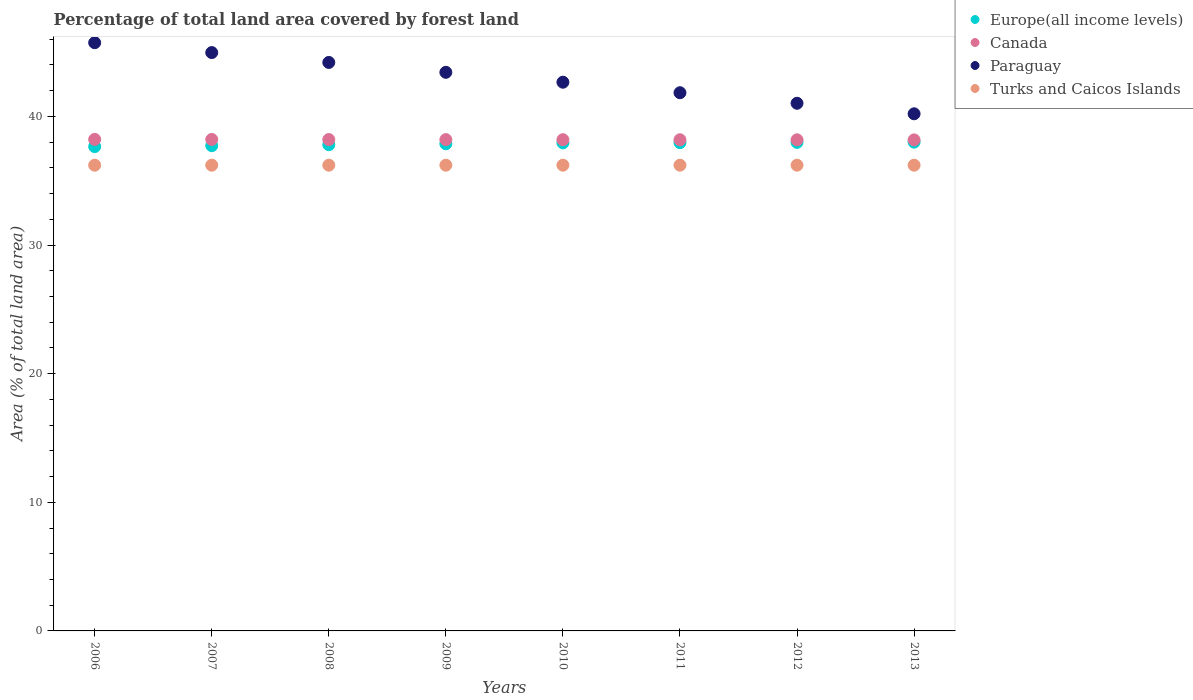How many different coloured dotlines are there?
Provide a succinct answer. 4. What is the percentage of forest land in Paraguay in 2011?
Offer a very short reply. 41.84. Across all years, what is the maximum percentage of forest land in Canada?
Your answer should be compact. 38.22. Across all years, what is the minimum percentage of forest land in Canada?
Your answer should be compact. 38.18. In which year was the percentage of forest land in Turks and Caicos Islands maximum?
Offer a very short reply. 2006. What is the total percentage of forest land in Paraguay in the graph?
Provide a short and direct response. 344.07. What is the difference between the percentage of forest land in Canada in 2009 and the percentage of forest land in Paraguay in 2012?
Ensure brevity in your answer.  -2.83. What is the average percentage of forest land in Canada per year?
Your response must be concise. 38.2. In the year 2013, what is the difference between the percentage of forest land in Paraguay and percentage of forest land in Europe(all income levels)?
Your answer should be compact. 2.2. What is the ratio of the percentage of forest land in Paraguay in 2010 to that in 2013?
Ensure brevity in your answer.  1.06. Is the percentage of forest land in Canada in 2010 less than that in 2013?
Make the answer very short. No. What is the difference between the highest and the second highest percentage of forest land in Paraguay?
Your answer should be compact. 0.77. What is the difference between the highest and the lowest percentage of forest land in Turks and Caicos Islands?
Your answer should be compact. 0. In how many years, is the percentage of forest land in Canada greater than the average percentage of forest land in Canada taken over all years?
Make the answer very short. 4. Is it the case that in every year, the sum of the percentage of forest land in Turks and Caicos Islands and percentage of forest land in Europe(all income levels)  is greater than the sum of percentage of forest land in Paraguay and percentage of forest land in Canada?
Provide a succinct answer. No. Does the percentage of forest land in Turks and Caicos Islands monotonically increase over the years?
Ensure brevity in your answer.  No. Is the percentage of forest land in Europe(all income levels) strictly less than the percentage of forest land in Paraguay over the years?
Keep it short and to the point. Yes. What is the difference between two consecutive major ticks on the Y-axis?
Keep it short and to the point. 10. Does the graph contain any zero values?
Ensure brevity in your answer.  No. Does the graph contain grids?
Your answer should be very brief. No. How are the legend labels stacked?
Offer a very short reply. Vertical. What is the title of the graph?
Offer a very short reply. Percentage of total land area covered by forest land. What is the label or title of the Y-axis?
Ensure brevity in your answer.  Area (% of total land area). What is the Area (% of total land area) of Europe(all income levels) in 2006?
Offer a terse response. 37.66. What is the Area (% of total land area) in Canada in 2006?
Provide a short and direct response. 38.22. What is the Area (% of total land area) of Paraguay in 2006?
Provide a short and direct response. 45.73. What is the Area (% of total land area) of Turks and Caicos Islands in 2006?
Your response must be concise. 36.21. What is the Area (% of total land area) of Europe(all income levels) in 2007?
Provide a succinct answer. 37.73. What is the Area (% of total land area) of Canada in 2007?
Ensure brevity in your answer.  38.21. What is the Area (% of total land area) in Paraguay in 2007?
Your answer should be very brief. 44.97. What is the Area (% of total land area) of Turks and Caicos Islands in 2007?
Provide a succinct answer. 36.21. What is the Area (% of total land area) in Europe(all income levels) in 2008?
Provide a short and direct response. 37.8. What is the Area (% of total land area) in Canada in 2008?
Offer a terse response. 38.2. What is the Area (% of total land area) of Paraguay in 2008?
Your answer should be very brief. 44.2. What is the Area (% of total land area) of Turks and Caicos Islands in 2008?
Your answer should be compact. 36.21. What is the Area (% of total land area) of Europe(all income levels) in 2009?
Your answer should be compact. 37.87. What is the Area (% of total land area) of Canada in 2009?
Ensure brevity in your answer.  38.2. What is the Area (% of total land area) in Paraguay in 2009?
Offer a terse response. 43.43. What is the Area (% of total land area) in Turks and Caicos Islands in 2009?
Ensure brevity in your answer.  36.21. What is the Area (% of total land area) of Europe(all income levels) in 2010?
Provide a succinct answer. 37.94. What is the Area (% of total land area) of Canada in 2010?
Ensure brevity in your answer.  38.19. What is the Area (% of total land area) in Paraguay in 2010?
Make the answer very short. 42.66. What is the Area (% of total land area) of Turks and Caicos Islands in 2010?
Your answer should be compact. 36.21. What is the Area (% of total land area) of Europe(all income levels) in 2011?
Your answer should be very brief. 37.96. What is the Area (% of total land area) in Canada in 2011?
Your answer should be compact. 38.19. What is the Area (% of total land area) of Paraguay in 2011?
Keep it short and to the point. 41.84. What is the Area (% of total land area) in Turks and Caicos Islands in 2011?
Give a very brief answer. 36.21. What is the Area (% of total land area) of Europe(all income levels) in 2012?
Keep it short and to the point. 37.98. What is the Area (% of total land area) of Canada in 2012?
Make the answer very short. 38.18. What is the Area (% of total land area) of Paraguay in 2012?
Give a very brief answer. 41.02. What is the Area (% of total land area) of Turks and Caicos Islands in 2012?
Your response must be concise. 36.21. What is the Area (% of total land area) of Europe(all income levels) in 2013?
Your answer should be very brief. 38. What is the Area (% of total land area) of Canada in 2013?
Offer a very short reply. 38.18. What is the Area (% of total land area) in Paraguay in 2013?
Offer a terse response. 40.21. What is the Area (% of total land area) in Turks and Caicos Islands in 2013?
Your answer should be compact. 36.21. Across all years, what is the maximum Area (% of total land area) in Europe(all income levels)?
Offer a terse response. 38. Across all years, what is the maximum Area (% of total land area) of Canada?
Provide a succinct answer. 38.22. Across all years, what is the maximum Area (% of total land area) of Paraguay?
Make the answer very short. 45.73. Across all years, what is the maximum Area (% of total land area) in Turks and Caicos Islands?
Ensure brevity in your answer.  36.21. Across all years, what is the minimum Area (% of total land area) of Europe(all income levels)?
Offer a very short reply. 37.66. Across all years, what is the minimum Area (% of total land area) in Canada?
Offer a terse response. 38.18. Across all years, what is the minimum Area (% of total land area) in Paraguay?
Your answer should be compact. 40.21. Across all years, what is the minimum Area (% of total land area) in Turks and Caicos Islands?
Ensure brevity in your answer.  36.21. What is the total Area (% of total land area) of Europe(all income levels) in the graph?
Give a very brief answer. 302.95. What is the total Area (% of total land area) of Canada in the graph?
Give a very brief answer. 305.57. What is the total Area (% of total land area) of Paraguay in the graph?
Give a very brief answer. 344.07. What is the total Area (% of total land area) of Turks and Caicos Islands in the graph?
Your answer should be compact. 289.68. What is the difference between the Area (% of total land area) in Europe(all income levels) in 2006 and that in 2007?
Provide a succinct answer. -0.07. What is the difference between the Area (% of total land area) of Canada in 2006 and that in 2007?
Offer a very short reply. 0.01. What is the difference between the Area (% of total land area) of Paraguay in 2006 and that in 2007?
Ensure brevity in your answer.  0.77. What is the difference between the Area (% of total land area) of Europe(all income levels) in 2006 and that in 2008?
Give a very brief answer. -0.15. What is the difference between the Area (% of total land area) in Canada in 2006 and that in 2008?
Your answer should be very brief. 0.01. What is the difference between the Area (% of total land area) of Paraguay in 2006 and that in 2008?
Keep it short and to the point. 1.54. What is the difference between the Area (% of total land area) of Turks and Caicos Islands in 2006 and that in 2008?
Ensure brevity in your answer.  0. What is the difference between the Area (% of total land area) of Europe(all income levels) in 2006 and that in 2009?
Keep it short and to the point. -0.22. What is the difference between the Area (% of total land area) in Canada in 2006 and that in 2009?
Your answer should be very brief. 0.02. What is the difference between the Area (% of total land area) in Paraguay in 2006 and that in 2009?
Ensure brevity in your answer.  2.3. What is the difference between the Area (% of total land area) of Turks and Caicos Islands in 2006 and that in 2009?
Make the answer very short. 0. What is the difference between the Area (% of total land area) of Europe(all income levels) in 2006 and that in 2010?
Offer a terse response. -0.29. What is the difference between the Area (% of total land area) in Canada in 2006 and that in 2010?
Your answer should be very brief. 0.02. What is the difference between the Area (% of total land area) in Paraguay in 2006 and that in 2010?
Your answer should be very brief. 3.07. What is the difference between the Area (% of total land area) in Turks and Caicos Islands in 2006 and that in 2010?
Provide a succinct answer. 0. What is the difference between the Area (% of total land area) of Europe(all income levels) in 2006 and that in 2011?
Your answer should be very brief. -0.31. What is the difference between the Area (% of total land area) in Canada in 2006 and that in 2011?
Provide a succinct answer. 0.03. What is the difference between the Area (% of total land area) of Paraguay in 2006 and that in 2011?
Keep it short and to the point. 3.89. What is the difference between the Area (% of total land area) in Europe(all income levels) in 2006 and that in 2012?
Offer a very short reply. -0.33. What is the difference between the Area (% of total land area) in Canada in 2006 and that in 2012?
Your answer should be compact. 0.03. What is the difference between the Area (% of total land area) in Paraguay in 2006 and that in 2012?
Make the answer very short. 4.71. What is the difference between the Area (% of total land area) of Europe(all income levels) in 2006 and that in 2013?
Provide a succinct answer. -0.35. What is the difference between the Area (% of total land area) in Canada in 2006 and that in 2013?
Your answer should be very brief. 0.04. What is the difference between the Area (% of total land area) in Paraguay in 2006 and that in 2013?
Provide a succinct answer. 5.53. What is the difference between the Area (% of total land area) of Europe(all income levels) in 2007 and that in 2008?
Your answer should be very brief. -0.07. What is the difference between the Area (% of total land area) of Canada in 2007 and that in 2008?
Provide a short and direct response. 0.01. What is the difference between the Area (% of total land area) of Paraguay in 2007 and that in 2008?
Give a very brief answer. 0.77. What is the difference between the Area (% of total land area) of Turks and Caicos Islands in 2007 and that in 2008?
Your answer should be very brief. 0. What is the difference between the Area (% of total land area) of Europe(all income levels) in 2007 and that in 2009?
Your response must be concise. -0.15. What is the difference between the Area (% of total land area) of Canada in 2007 and that in 2009?
Offer a very short reply. 0.01. What is the difference between the Area (% of total land area) of Paraguay in 2007 and that in 2009?
Ensure brevity in your answer.  1.54. What is the difference between the Area (% of total land area) in Europe(all income levels) in 2007 and that in 2010?
Give a very brief answer. -0.22. What is the difference between the Area (% of total land area) in Canada in 2007 and that in 2010?
Provide a short and direct response. 0.02. What is the difference between the Area (% of total land area) in Paraguay in 2007 and that in 2010?
Provide a succinct answer. 2.3. What is the difference between the Area (% of total land area) in Turks and Caicos Islands in 2007 and that in 2010?
Keep it short and to the point. 0. What is the difference between the Area (% of total land area) of Europe(all income levels) in 2007 and that in 2011?
Keep it short and to the point. -0.23. What is the difference between the Area (% of total land area) in Canada in 2007 and that in 2011?
Provide a succinct answer. 0.02. What is the difference between the Area (% of total land area) of Paraguay in 2007 and that in 2011?
Your answer should be compact. 3.12. What is the difference between the Area (% of total land area) in Turks and Caicos Islands in 2007 and that in 2011?
Provide a short and direct response. 0. What is the difference between the Area (% of total land area) of Europe(all income levels) in 2007 and that in 2012?
Your response must be concise. -0.26. What is the difference between the Area (% of total land area) in Canada in 2007 and that in 2012?
Your response must be concise. 0.03. What is the difference between the Area (% of total land area) in Paraguay in 2007 and that in 2012?
Offer a very short reply. 3.94. What is the difference between the Area (% of total land area) in Europe(all income levels) in 2007 and that in 2013?
Your answer should be compact. -0.27. What is the difference between the Area (% of total land area) of Canada in 2007 and that in 2013?
Make the answer very short. 0.03. What is the difference between the Area (% of total land area) of Paraguay in 2007 and that in 2013?
Your answer should be compact. 4.76. What is the difference between the Area (% of total land area) in Europe(all income levels) in 2008 and that in 2009?
Offer a terse response. -0.07. What is the difference between the Area (% of total land area) of Canada in 2008 and that in 2009?
Offer a terse response. 0.01. What is the difference between the Area (% of total land area) in Paraguay in 2008 and that in 2009?
Your response must be concise. 0.77. What is the difference between the Area (% of total land area) of Europe(all income levels) in 2008 and that in 2010?
Keep it short and to the point. -0.14. What is the difference between the Area (% of total land area) of Canada in 2008 and that in 2010?
Provide a short and direct response. 0.01. What is the difference between the Area (% of total land area) of Paraguay in 2008 and that in 2010?
Make the answer very short. 1.54. What is the difference between the Area (% of total land area) of Turks and Caicos Islands in 2008 and that in 2010?
Provide a succinct answer. 0. What is the difference between the Area (% of total land area) of Europe(all income levels) in 2008 and that in 2011?
Ensure brevity in your answer.  -0.16. What is the difference between the Area (% of total land area) in Canada in 2008 and that in 2011?
Offer a very short reply. 0.02. What is the difference between the Area (% of total land area) of Paraguay in 2008 and that in 2011?
Give a very brief answer. 2.35. What is the difference between the Area (% of total land area) of Europe(all income levels) in 2008 and that in 2012?
Your answer should be compact. -0.18. What is the difference between the Area (% of total land area) in Canada in 2008 and that in 2012?
Keep it short and to the point. 0.02. What is the difference between the Area (% of total land area) in Paraguay in 2008 and that in 2012?
Your response must be concise. 3.17. What is the difference between the Area (% of total land area) in Turks and Caicos Islands in 2008 and that in 2012?
Make the answer very short. 0. What is the difference between the Area (% of total land area) of Europe(all income levels) in 2008 and that in 2013?
Offer a very short reply. -0.2. What is the difference between the Area (% of total land area) of Canada in 2008 and that in 2013?
Offer a terse response. 0.03. What is the difference between the Area (% of total land area) in Paraguay in 2008 and that in 2013?
Provide a succinct answer. 3.99. What is the difference between the Area (% of total land area) of Europe(all income levels) in 2009 and that in 2010?
Ensure brevity in your answer.  -0.07. What is the difference between the Area (% of total land area) of Canada in 2009 and that in 2010?
Your answer should be very brief. 0.01. What is the difference between the Area (% of total land area) of Paraguay in 2009 and that in 2010?
Provide a succinct answer. 0.77. What is the difference between the Area (% of total land area) of Turks and Caicos Islands in 2009 and that in 2010?
Offer a very short reply. 0. What is the difference between the Area (% of total land area) of Europe(all income levels) in 2009 and that in 2011?
Provide a short and direct response. -0.09. What is the difference between the Area (% of total land area) of Canada in 2009 and that in 2011?
Ensure brevity in your answer.  0.01. What is the difference between the Area (% of total land area) of Paraguay in 2009 and that in 2011?
Provide a succinct answer. 1.59. What is the difference between the Area (% of total land area) of Turks and Caicos Islands in 2009 and that in 2011?
Provide a short and direct response. 0. What is the difference between the Area (% of total land area) in Europe(all income levels) in 2009 and that in 2012?
Offer a terse response. -0.11. What is the difference between the Area (% of total land area) of Canada in 2009 and that in 2012?
Provide a short and direct response. 0.02. What is the difference between the Area (% of total land area) in Paraguay in 2009 and that in 2012?
Offer a terse response. 2.41. What is the difference between the Area (% of total land area) in Turks and Caicos Islands in 2009 and that in 2012?
Your response must be concise. 0. What is the difference between the Area (% of total land area) in Europe(all income levels) in 2009 and that in 2013?
Your response must be concise. -0.13. What is the difference between the Area (% of total land area) of Canada in 2009 and that in 2013?
Your answer should be very brief. 0.02. What is the difference between the Area (% of total land area) in Paraguay in 2009 and that in 2013?
Provide a short and direct response. 3.22. What is the difference between the Area (% of total land area) in Europe(all income levels) in 2010 and that in 2011?
Give a very brief answer. -0.02. What is the difference between the Area (% of total land area) of Canada in 2010 and that in 2011?
Your answer should be very brief. 0.01. What is the difference between the Area (% of total land area) in Paraguay in 2010 and that in 2011?
Make the answer very short. 0.82. What is the difference between the Area (% of total land area) in Turks and Caicos Islands in 2010 and that in 2011?
Your response must be concise. 0. What is the difference between the Area (% of total land area) of Europe(all income levels) in 2010 and that in 2012?
Ensure brevity in your answer.  -0.04. What is the difference between the Area (% of total land area) in Canada in 2010 and that in 2012?
Provide a short and direct response. 0.01. What is the difference between the Area (% of total land area) of Paraguay in 2010 and that in 2012?
Provide a succinct answer. 1.64. What is the difference between the Area (% of total land area) in Turks and Caicos Islands in 2010 and that in 2012?
Make the answer very short. 0. What is the difference between the Area (% of total land area) of Europe(all income levels) in 2010 and that in 2013?
Provide a succinct answer. -0.06. What is the difference between the Area (% of total land area) of Canada in 2010 and that in 2013?
Keep it short and to the point. 0.02. What is the difference between the Area (% of total land area) of Paraguay in 2010 and that in 2013?
Make the answer very short. 2.46. What is the difference between the Area (% of total land area) in Europe(all income levels) in 2011 and that in 2012?
Your answer should be compact. -0.02. What is the difference between the Area (% of total land area) in Canada in 2011 and that in 2012?
Provide a short and direct response. 0.01. What is the difference between the Area (% of total land area) in Paraguay in 2011 and that in 2012?
Your answer should be very brief. 0.82. What is the difference between the Area (% of total land area) of Turks and Caicos Islands in 2011 and that in 2012?
Your answer should be very brief. 0. What is the difference between the Area (% of total land area) of Europe(all income levels) in 2011 and that in 2013?
Provide a succinct answer. -0.04. What is the difference between the Area (% of total land area) in Canada in 2011 and that in 2013?
Your answer should be compact. 0.01. What is the difference between the Area (% of total land area) in Paraguay in 2011 and that in 2013?
Offer a very short reply. 1.64. What is the difference between the Area (% of total land area) of Turks and Caicos Islands in 2011 and that in 2013?
Your answer should be compact. 0. What is the difference between the Area (% of total land area) of Europe(all income levels) in 2012 and that in 2013?
Your answer should be very brief. -0.02. What is the difference between the Area (% of total land area) of Canada in 2012 and that in 2013?
Your response must be concise. 0.01. What is the difference between the Area (% of total land area) in Paraguay in 2012 and that in 2013?
Provide a short and direct response. 0.82. What is the difference between the Area (% of total land area) of Turks and Caicos Islands in 2012 and that in 2013?
Provide a succinct answer. 0. What is the difference between the Area (% of total land area) in Europe(all income levels) in 2006 and the Area (% of total land area) in Canada in 2007?
Provide a succinct answer. -0.55. What is the difference between the Area (% of total land area) in Europe(all income levels) in 2006 and the Area (% of total land area) in Paraguay in 2007?
Ensure brevity in your answer.  -7.31. What is the difference between the Area (% of total land area) of Europe(all income levels) in 2006 and the Area (% of total land area) of Turks and Caicos Islands in 2007?
Offer a terse response. 1.45. What is the difference between the Area (% of total land area) of Canada in 2006 and the Area (% of total land area) of Paraguay in 2007?
Make the answer very short. -6.75. What is the difference between the Area (% of total land area) in Canada in 2006 and the Area (% of total land area) in Turks and Caicos Islands in 2007?
Provide a short and direct response. 2.01. What is the difference between the Area (% of total land area) of Paraguay in 2006 and the Area (% of total land area) of Turks and Caicos Islands in 2007?
Make the answer very short. 9.52. What is the difference between the Area (% of total land area) of Europe(all income levels) in 2006 and the Area (% of total land area) of Canada in 2008?
Make the answer very short. -0.55. What is the difference between the Area (% of total land area) in Europe(all income levels) in 2006 and the Area (% of total land area) in Paraguay in 2008?
Offer a terse response. -6.54. What is the difference between the Area (% of total land area) in Europe(all income levels) in 2006 and the Area (% of total land area) in Turks and Caicos Islands in 2008?
Your response must be concise. 1.45. What is the difference between the Area (% of total land area) of Canada in 2006 and the Area (% of total land area) of Paraguay in 2008?
Offer a terse response. -5.98. What is the difference between the Area (% of total land area) in Canada in 2006 and the Area (% of total land area) in Turks and Caicos Islands in 2008?
Offer a very short reply. 2.01. What is the difference between the Area (% of total land area) in Paraguay in 2006 and the Area (% of total land area) in Turks and Caicos Islands in 2008?
Ensure brevity in your answer.  9.52. What is the difference between the Area (% of total land area) in Europe(all income levels) in 2006 and the Area (% of total land area) in Canada in 2009?
Provide a short and direct response. -0.54. What is the difference between the Area (% of total land area) in Europe(all income levels) in 2006 and the Area (% of total land area) in Paraguay in 2009?
Provide a succinct answer. -5.78. What is the difference between the Area (% of total land area) in Europe(all income levels) in 2006 and the Area (% of total land area) in Turks and Caicos Islands in 2009?
Your answer should be compact. 1.45. What is the difference between the Area (% of total land area) of Canada in 2006 and the Area (% of total land area) of Paraguay in 2009?
Give a very brief answer. -5.21. What is the difference between the Area (% of total land area) of Canada in 2006 and the Area (% of total land area) of Turks and Caicos Islands in 2009?
Offer a terse response. 2.01. What is the difference between the Area (% of total land area) of Paraguay in 2006 and the Area (% of total land area) of Turks and Caicos Islands in 2009?
Keep it short and to the point. 9.52. What is the difference between the Area (% of total land area) of Europe(all income levels) in 2006 and the Area (% of total land area) of Canada in 2010?
Give a very brief answer. -0.54. What is the difference between the Area (% of total land area) of Europe(all income levels) in 2006 and the Area (% of total land area) of Paraguay in 2010?
Make the answer very short. -5.01. What is the difference between the Area (% of total land area) in Europe(all income levels) in 2006 and the Area (% of total land area) in Turks and Caicos Islands in 2010?
Your response must be concise. 1.45. What is the difference between the Area (% of total land area) in Canada in 2006 and the Area (% of total land area) in Paraguay in 2010?
Keep it short and to the point. -4.45. What is the difference between the Area (% of total land area) of Canada in 2006 and the Area (% of total land area) of Turks and Caicos Islands in 2010?
Offer a very short reply. 2.01. What is the difference between the Area (% of total land area) of Paraguay in 2006 and the Area (% of total land area) of Turks and Caicos Islands in 2010?
Make the answer very short. 9.52. What is the difference between the Area (% of total land area) in Europe(all income levels) in 2006 and the Area (% of total land area) in Canada in 2011?
Your response must be concise. -0.53. What is the difference between the Area (% of total land area) of Europe(all income levels) in 2006 and the Area (% of total land area) of Paraguay in 2011?
Offer a terse response. -4.19. What is the difference between the Area (% of total land area) in Europe(all income levels) in 2006 and the Area (% of total land area) in Turks and Caicos Islands in 2011?
Your answer should be very brief. 1.45. What is the difference between the Area (% of total land area) in Canada in 2006 and the Area (% of total land area) in Paraguay in 2011?
Offer a terse response. -3.63. What is the difference between the Area (% of total land area) of Canada in 2006 and the Area (% of total land area) of Turks and Caicos Islands in 2011?
Make the answer very short. 2.01. What is the difference between the Area (% of total land area) of Paraguay in 2006 and the Area (% of total land area) of Turks and Caicos Islands in 2011?
Make the answer very short. 9.52. What is the difference between the Area (% of total land area) in Europe(all income levels) in 2006 and the Area (% of total land area) in Canada in 2012?
Your answer should be very brief. -0.53. What is the difference between the Area (% of total land area) of Europe(all income levels) in 2006 and the Area (% of total land area) of Paraguay in 2012?
Keep it short and to the point. -3.37. What is the difference between the Area (% of total land area) of Europe(all income levels) in 2006 and the Area (% of total land area) of Turks and Caicos Islands in 2012?
Give a very brief answer. 1.45. What is the difference between the Area (% of total land area) of Canada in 2006 and the Area (% of total land area) of Paraguay in 2012?
Give a very brief answer. -2.81. What is the difference between the Area (% of total land area) of Canada in 2006 and the Area (% of total land area) of Turks and Caicos Islands in 2012?
Provide a short and direct response. 2.01. What is the difference between the Area (% of total land area) of Paraguay in 2006 and the Area (% of total land area) of Turks and Caicos Islands in 2012?
Offer a terse response. 9.52. What is the difference between the Area (% of total land area) in Europe(all income levels) in 2006 and the Area (% of total land area) in Canada in 2013?
Offer a terse response. -0.52. What is the difference between the Area (% of total land area) of Europe(all income levels) in 2006 and the Area (% of total land area) of Paraguay in 2013?
Your answer should be very brief. -2.55. What is the difference between the Area (% of total land area) in Europe(all income levels) in 2006 and the Area (% of total land area) in Turks and Caicos Islands in 2013?
Ensure brevity in your answer.  1.45. What is the difference between the Area (% of total land area) of Canada in 2006 and the Area (% of total land area) of Paraguay in 2013?
Give a very brief answer. -1.99. What is the difference between the Area (% of total land area) in Canada in 2006 and the Area (% of total land area) in Turks and Caicos Islands in 2013?
Your response must be concise. 2.01. What is the difference between the Area (% of total land area) in Paraguay in 2006 and the Area (% of total land area) in Turks and Caicos Islands in 2013?
Offer a terse response. 9.52. What is the difference between the Area (% of total land area) in Europe(all income levels) in 2007 and the Area (% of total land area) in Canada in 2008?
Provide a succinct answer. -0.48. What is the difference between the Area (% of total land area) of Europe(all income levels) in 2007 and the Area (% of total land area) of Paraguay in 2008?
Ensure brevity in your answer.  -6.47. What is the difference between the Area (% of total land area) in Europe(all income levels) in 2007 and the Area (% of total land area) in Turks and Caicos Islands in 2008?
Give a very brief answer. 1.52. What is the difference between the Area (% of total land area) of Canada in 2007 and the Area (% of total land area) of Paraguay in 2008?
Your response must be concise. -5.99. What is the difference between the Area (% of total land area) in Canada in 2007 and the Area (% of total land area) in Turks and Caicos Islands in 2008?
Your answer should be compact. 2. What is the difference between the Area (% of total land area) in Paraguay in 2007 and the Area (% of total land area) in Turks and Caicos Islands in 2008?
Offer a terse response. 8.76. What is the difference between the Area (% of total land area) of Europe(all income levels) in 2007 and the Area (% of total land area) of Canada in 2009?
Offer a terse response. -0.47. What is the difference between the Area (% of total land area) of Europe(all income levels) in 2007 and the Area (% of total land area) of Paraguay in 2009?
Your response must be concise. -5.7. What is the difference between the Area (% of total land area) of Europe(all income levels) in 2007 and the Area (% of total land area) of Turks and Caicos Islands in 2009?
Keep it short and to the point. 1.52. What is the difference between the Area (% of total land area) of Canada in 2007 and the Area (% of total land area) of Paraguay in 2009?
Offer a very short reply. -5.22. What is the difference between the Area (% of total land area) of Canada in 2007 and the Area (% of total land area) of Turks and Caicos Islands in 2009?
Your answer should be compact. 2. What is the difference between the Area (% of total land area) of Paraguay in 2007 and the Area (% of total land area) of Turks and Caicos Islands in 2009?
Keep it short and to the point. 8.76. What is the difference between the Area (% of total land area) in Europe(all income levels) in 2007 and the Area (% of total land area) in Canada in 2010?
Keep it short and to the point. -0.46. What is the difference between the Area (% of total land area) of Europe(all income levels) in 2007 and the Area (% of total land area) of Paraguay in 2010?
Your response must be concise. -4.93. What is the difference between the Area (% of total land area) in Europe(all income levels) in 2007 and the Area (% of total land area) in Turks and Caicos Islands in 2010?
Make the answer very short. 1.52. What is the difference between the Area (% of total land area) of Canada in 2007 and the Area (% of total land area) of Paraguay in 2010?
Your answer should be compact. -4.45. What is the difference between the Area (% of total land area) of Canada in 2007 and the Area (% of total land area) of Turks and Caicos Islands in 2010?
Provide a short and direct response. 2. What is the difference between the Area (% of total land area) in Paraguay in 2007 and the Area (% of total land area) in Turks and Caicos Islands in 2010?
Your response must be concise. 8.76. What is the difference between the Area (% of total land area) of Europe(all income levels) in 2007 and the Area (% of total land area) of Canada in 2011?
Your response must be concise. -0.46. What is the difference between the Area (% of total land area) in Europe(all income levels) in 2007 and the Area (% of total land area) in Paraguay in 2011?
Make the answer very short. -4.12. What is the difference between the Area (% of total land area) of Europe(all income levels) in 2007 and the Area (% of total land area) of Turks and Caicos Islands in 2011?
Your response must be concise. 1.52. What is the difference between the Area (% of total land area) in Canada in 2007 and the Area (% of total land area) in Paraguay in 2011?
Your answer should be compact. -3.63. What is the difference between the Area (% of total land area) in Canada in 2007 and the Area (% of total land area) in Turks and Caicos Islands in 2011?
Your answer should be very brief. 2. What is the difference between the Area (% of total land area) in Paraguay in 2007 and the Area (% of total land area) in Turks and Caicos Islands in 2011?
Your response must be concise. 8.76. What is the difference between the Area (% of total land area) in Europe(all income levels) in 2007 and the Area (% of total land area) in Canada in 2012?
Give a very brief answer. -0.45. What is the difference between the Area (% of total land area) in Europe(all income levels) in 2007 and the Area (% of total land area) in Paraguay in 2012?
Give a very brief answer. -3.3. What is the difference between the Area (% of total land area) of Europe(all income levels) in 2007 and the Area (% of total land area) of Turks and Caicos Islands in 2012?
Your response must be concise. 1.52. What is the difference between the Area (% of total land area) of Canada in 2007 and the Area (% of total land area) of Paraguay in 2012?
Your answer should be very brief. -2.81. What is the difference between the Area (% of total land area) in Canada in 2007 and the Area (% of total land area) in Turks and Caicos Islands in 2012?
Provide a short and direct response. 2. What is the difference between the Area (% of total land area) of Paraguay in 2007 and the Area (% of total land area) of Turks and Caicos Islands in 2012?
Your answer should be compact. 8.76. What is the difference between the Area (% of total land area) of Europe(all income levels) in 2007 and the Area (% of total land area) of Canada in 2013?
Give a very brief answer. -0.45. What is the difference between the Area (% of total land area) of Europe(all income levels) in 2007 and the Area (% of total land area) of Paraguay in 2013?
Offer a terse response. -2.48. What is the difference between the Area (% of total land area) in Europe(all income levels) in 2007 and the Area (% of total land area) in Turks and Caicos Islands in 2013?
Offer a very short reply. 1.52. What is the difference between the Area (% of total land area) in Canada in 2007 and the Area (% of total land area) in Paraguay in 2013?
Provide a succinct answer. -2. What is the difference between the Area (% of total land area) of Canada in 2007 and the Area (% of total land area) of Turks and Caicos Islands in 2013?
Your answer should be compact. 2. What is the difference between the Area (% of total land area) in Paraguay in 2007 and the Area (% of total land area) in Turks and Caicos Islands in 2013?
Your response must be concise. 8.76. What is the difference between the Area (% of total land area) in Europe(all income levels) in 2008 and the Area (% of total land area) in Canada in 2009?
Offer a very short reply. -0.4. What is the difference between the Area (% of total land area) in Europe(all income levels) in 2008 and the Area (% of total land area) in Paraguay in 2009?
Offer a terse response. -5.63. What is the difference between the Area (% of total land area) in Europe(all income levels) in 2008 and the Area (% of total land area) in Turks and Caicos Islands in 2009?
Provide a succinct answer. 1.59. What is the difference between the Area (% of total land area) of Canada in 2008 and the Area (% of total land area) of Paraguay in 2009?
Give a very brief answer. -5.23. What is the difference between the Area (% of total land area) of Canada in 2008 and the Area (% of total land area) of Turks and Caicos Islands in 2009?
Make the answer very short. 1.99. What is the difference between the Area (% of total land area) in Paraguay in 2008 and the Area (% of total land area) in Turks and Caicos Islands in 2009?
Offer a very short reply. 7.99. What is the difference between the Area (% of total land area) in Europe(all income levels) in 2008 and the Area (% of total land area) in Canada in 2010?
Give a very brief answer. -0.39. What is the difference between the Area (% of total land area) of Europe(all income levels) in 2008 and the Area (% of total land area) of Paraguay in 2010?
Your answer should be compact. -4.86. What is the difference between the Area (% of total land area) in Europe(all income levels) in 2008 and the Area (% of total land area) in Turks and Caicos Islands in 2010?
Provide a short and direct response. 1.59. What is the difference between the Area (% of total land area) of Canada in 2008 and the Area (% of total land area) of Paraguay in 2010?
Ensure brevity in your answer.  -4.46. What is the difference between the Area (% of total land area) of Canada in 2008 and the Area (% of total land area) of Turks and Caicos Islands in 2010?
Ensure brevity in your answer.  1.99. What is the difference between the Area (% of total land area) of Paraguay in 2008 and the Area (% of total land area) of Turks and Caicos Islands in 2010?
Keep it short and to the point. 7.99. What is the difference between the Area (% of total land area) of Europe(all income levels) in 2008 and the Area (% of total land area) of Canada in 2011?
Your answer should be very brief. -0.38. What is the difference between the Area (% of total land area) of Europe(all income levels) in 2008 and the Area (% of total land area) of Paraguay in 2011?
Provide a short and direct response. -4.04. What is the difference between the Area (% of total land area) of Europe(all income levels) in 2008 and the Area (% of total land area) of Turks and Caicos Islands in 2011?
Ensure brevity in your answer.  1.59. What is the difference between the Area (% of total land area) of Canada in 2008 and the Area (% of total land area) of Paraguay in 2011?
Give a very brief answer. -3.64. What is the difference between the Area (% of total land area) of Canada in 2008 and the Area (% of total land area) of Turks and Caicos Islands in 2011?
Give a very brief answer. 1.99. What is the difference between the Area (% of total land area) in Paraguay in 2008 and the Area (% of total land area) in Turks and Caicos Islands in 2011?
Provide a succinct answer. 7.99. What is the difference between the Area (% of total land area) of Europe(all income levels) in 2008 and the Area (% of total land area) of Canada in 2012?
Your answer should be very brief. -0.38. What is the difference between the Area (% of total land area) of Europe(all income levels) in 2008 and the Area (% of total land area) of Paraguay in 2012?
Provide a succinct answer. -3.22. What is the difference between the Area (% of total land area) of Europe(all income levels) in 2008 and the Area (% of total land area) of Turks and Caicos Islands in 2012?
Ensure brevity in your answer.  1.59. What is the difference between the Area (% of total land area) of Canada in 2008 and the Area (% of total land area) of Paraguay in 2012?
Your answer should be very brief. -2.82. What is the difference between the Area (% of total land area) in Canada in 2008 and the Area (% of total land area) in Turks and Caicos Islands in 2012?
Give a very brief answer. 1.99. What is the difference between the Area (% of total land area) in Paraguay in 2008 and the Area (% of total land area) in Turks and Caicos Islands in 2012?
Offer a very short reply. 7.99. What is the difference between the Area (% of total land area) of Europe(all income levels) in 2008 and the Area (% of total land area) of Canada in 2013?
Your response must be concise. -0.37. What is the difference between the Area (% of total land area) of Europe(all income levels) in 2008 and the Area (% of total land area) of Paraguay in 2013?
Keep it short and to the point. -2.4. What is the difference between the Area (% of total land area) in Europe(all income levels) in 2008 and the Area (% of total land area) in Turks and Caicos Islands in 2013?
Ensure brevity in your answer.  1.59. What is the difference between the Area (% of total land area) of Canada in 2008 and the Area (% of total land area) of Paraguay in 2013?
Give a very brief answer. -2. What is the difference between the Area (% of total land area) of Canada in 2008 and the Area (% of total land area) of Turks and Caicos Islands in 2013?
Your answer should be very brief. 1.99. What is the difference between the Area (% of total land area) of Paraguay in 2008 and the Area (% of total land area) of Turks and Caicos Islands in 2013?
Your answer should be compact. 7.99. What is the difference between the Area (% of total land area) of Europe(all income levels) in 2009 and the Area (% of total land area) of Canada in 2010?
Offer a very short reply. -0.32. What is the difference between the Area (% of total land area) in Europe(all income levels) in 2009 and the Area (% of total land area) in Paraguay in 2010?
Provide a short and direct response. -4.79. What is the difference between the Area (% of total land area) in Europe(all income levels) in 2009 and the Area (% of total land area) in Turks and Caicos Islands in 2010?
Offer a very short reply. 1.66. What is the difference between the Area (% of total land area) of Canada in 2009 and the Area (% of total land area) of Paraguay in 2010?
Your response must be concise. -4.46. What is the difference between the Area (% of total land area) in Canada in 2009 and the Area (% of total land area) in Turks and Caicos Islands in 2010?
Give a very brief answer. 1.99. What is the difference between the Area (% of total land area) in Paraguay in 2009 and the Area (% of total land area) in Turks and Caicos Islands in 2010?
Provide a succinct answer. 7.22. What is the difference between the Area (% of total land area) of Europe(all income levels) in 2009 and the Area (% of total land area) of Canada in 2011?
Your response must be concise. -0.31. What is the difference between the Area (% of total land area) of Europe(all income levels) in 2009 and the Area (% of total land area) of Paraguay in 2011?
Offer a terse response. -3.97. What is the difference between the Area (% of total land area) in Europe(all income levels) in 2009 and the Area (% of total land area) in Turks and Caicos Islands in 2011?
Provide a short and direct response. 1.66. What is the difference between the Area (% of total land area) of Canada in 2009 and the Area (% of total land area) of Paraguay in 2011?
Provide a succinct answer. -3.65. What is the difference between the Area (% of total land area) of Canada in 2009 and the Area (% of total land area) of Turks and Caicos Islands in 2011?
Make the answer very short. 1.99. What is the difference between the Area (% of total land area) of Paraguay in 2009 and the Area (% of total land area) of Turks and Caicos Islands in 2011?
Make the answer very short. 7.22. What is the difference between the Area (% of total land area) in Europe(all income levels) in 2009 and the Area (% of total land area) in Canada in 2012?
Provide a short and direct response. -0.31. What is the difference between the Area (% of total land area) of Europe(all income levels) in 2009 and the Area (% of total land area) of Paraguay in 2012?
Keep it short and to the point. -3.15. What is the difference between the Area (% of total land area) in Europe(all income levels) in 2009 and the Area (% of total land area) in Turks and Caicos Islands in 2012?
Keep it short and to the point. 1.66. What is the difference between the Area (% of total land area) in Canada in 2009 and the Area (% of total land area) in Paraguay in 2012?
Provide a succinct answer. -2.83. What is the difference between the Area (% of total land area) in Canada in 2009 and the Area (% of total land area) in Turks and Caicos Islands in 2012?
Keep it short and to the point. 1.99. What is the difference between the Area (% of total land area) of Paraguay in 2009 and the Area (% of total land area) of Turks and Caicos Islands in 2012?
Keep it short and to the point. 7.22. What is the difference between the Area (% of total land area) of Europe(all income levels) in 2009 and the Area (% of total land area) of Canada in 2013?
Offer a terse response. -0.3. What is the difference between the Area (% of total land area) of Europe(all income levels) in 2009 and the Area (% of total land area) of Paraguay in 2013?
Offer a terse response. -2.33. What is the difference between the Area (% of total land area) of Europe(all income levels) in 2009 and the Area (% of total land area) of Turks and Caicos Islands in 2013?
Make the answer very short. 1.66. What is the difference between the Area (% of total land area) in Canada in 2009 and the Area (% of total land area) in Paraguay in 2013?
Provide a short and direct response. -2.01. What is the difference between the Area (% of total land area) in Canada in 2009 and the Area (% of total land area) in Turks and Caicos Islands in 2013?
Keep it short and to the point. 1.99. What is the difference between the Area (% of total land area) of Paraguay in 2009 and the Area (% of total land area) of Turks and Caicos Islands in 2013?
Keep it short and to the point. 7.22. What is the difference between the Area (% of total land area) of Europe(all income levels) in 2010 and the Area (% of total land area) of Canada in 2011?
Provide a short and direct response. -0.24. What is the difference between the Area (% of total land area) in Europe(all income levels) in 2010 and the Area (% of total land area) in Paraguay in 2011?
Your answer should be compact. -3.9. What is the difference between the Area (% of total land area) in Europe(all income levels) in 2010 and the Area (% of total land area) in Turks and Caicos Islands in 2011?
Make the answer very short. 1.73. What is the difference between the Area (% of total land area) in Canada in 2010 and the Area (% of total land area) in Paraguay in 2011?
Keep it short and to the point. -3.65. What is the difference between the Area (% of total land area) in Canada in 2010 and the Area (% of total land area) in Turks and Caicos Islands in 2011?
Keep it short and to the point. 1.98. What is the difference between the Area (% of total land area) of Paraguay in 2010 and the Area (% of total land area) of Turks and Caicos Islands in 2011?
Keep it short and to the point. 6.45. What is the difference between the Area (% of total land area) in Europe(all income levels) in 2010 and the Area (% of total land area) in Canada in 2012?
Offer a terse response. -0.24. What is the difference between the Area (% of total land area) of Europe(all income levels) in 2010 and the Area (% of total land area) of Paraguay in 2012?
Give a very brief answer. -3.08. What is the difference between the Area (% of total land area) of Europe(all income levels) in 2010 and the Area (% of total land area) of Turks and Caicos Islands in 2012?
Your answer should be compact. 1.73. What is the difference between the Area (% of total land area) in Canada in 2010 and the Area (% of total land area) in Paraguay in 2012?
Your response must be concise. -2.83. What is the difference between the Area (% of total land area) in Canada in 2010 and the Area (% of total land area) in Turks and Caicos Islands in 2012?
Offer a very short reply. 1.98. What is the difference between the Area (% of total land area) in Paraguay in 2010 and the Area (% of total land area) in Turks and Caicos Islands in 2012?
Provide a short and direct response. 6.45. What is the difference between the Area (% of total land area) in Europe(all income levels) in 2010 and the Area (% of total land area) in Canada in 2013?
Keep it short and to the point. -0.23. What is the difference between the Area (% of total land area) in Europe(all income levels) in 2010 and the Area (% of total land area) in Paraguay in 2013?
Your response must be concise. -2.26. What is the difference between the Area (% of total land area) of Europe(all income levels) in 2010 and the Area (% of total land area) of Turks and Caicos Islands in 2013?
Give a very brief answer. 1.73. What is the difference between the Area (% of total land area) of Canada in 2010 and the Area (% of total land area) of Paraguay in 2013?
Give a very brief answer. -2.01. What is the difference between the Area (% of total land area) of Canada in 2010 and the Area (% of total land area) of Turks and Caicos Islands in 2013?
Your answer should be compact. 1.98. What is the difference between the Area (% of total land area) in Paraguay in 2010 and the Area (% of total land area) in Turks and Caicos Islands in 2013?
Offer a very short reply. 6.45. What is the difference between the Area (% of total land area) of Europe(all income levels) in 2011 and the Area (% of total land area) of Canada in 2012?
Ensure brevity in your answer.  -0.22. What is the difference between the Area (% of total land area) of Europe(all income levels) in 2011 and the Area (% of total land area) of Paraguay in 2012?
Your response must be concise. -3.06. What is the difference between the Area (% of total land area) of Europe(all income levels) in 2011 and the Area (% of total land area) of Turks and Caicos Islands in 2012?
Make the answer very short. 1.75. What is the difference between the Area (% of total land area) of Canada in 2011 and the Area (% of total land area) of Paraguay in 2012?
Give a very brief answer. -2.84. What is the difference between the Area (% of total land area) in Canada in 2011 and the Area (% of total land area) in Turks and Caicos Islands in 2012?
Make the answer very short. 1.98. What is the difference between the Area (% of total land area) of Paraguay in 2011 and the Area (% of total land area) of Turks and Caicos Islands in 2012?
Provide a succinct answer. 5.63. What is the difference between the Area (% of total land area) of Europe(all income levels) in 2011 and the Area (% of total land area) of Canada in 2013?
Ensure brevity in your answer.  -0.21. What is the difference between the Area (% of total land area) of Europe(all income levels) in 2011 and the Area (% of total land area) of Paraguay in 2013?
Offer a terse response. -2.24. What is the difference between the Area (% of total land area) of Europe(all income levels) in 2011 and the Area (% of total land area) of Turks and Caicos Islands in 2013?
Your answer should be very brief. 1.75. What is the difference between the Area (% of total land area) in Canada in 2011 and the Area (% of total land area) in Paraguay in 2013?
Provide a short and direct response. -2.02. What is the difference between the Area (% of total land area) of Canada in 2011 and the Area (% of total land area) of Turks and Caicos Islands in 2013?
Your response must be concise. 1.98. What is the difference between the Area (% of total land area) of Paraguay in 2011 and the Area (% of total land area) of Turks and Caicos Islands in 2013?
Provide a short and direct response. 5.63. What is the difference between the Area (% of total land area) of Europe(all income levels) in 2012 and the Area (% of total land area) of Canada in 2013?
Your response must be concise. -0.19. What is the difference between the Area (% of total land area) of Europe(all income levels) in 2012 and the Area (% of total land area) of Paraguay in 2013?
Provide a short and direct response. -2.22. What is the difference between the Area (% of total land area) of Europe(all income levels) in 2012 and the Area (% of total land area) of Turks and Caicos Islands in 2013?
Give a very brief answer. 1.77. What is the difference between the Area (% of total land area) in Canada in 2012 and the Area (% of total land area) in Paraguay in 2013?
Provide a succinct answer. -2.02. What is the difference between the Area (% of total land area) of Canada in 2012 and the Area (% of total land area) of Turks and Caicos Islands in 2013?
Provide a succinct answer. 1.97. What is the difference between the Area (% of total land area) in Paraguay in 2012 and the Area (% of total land area) in Turks and Caicos Islands in 2013?
Your answer should be compact. 4.81. What is the average Area (% of total land area) of Europe(all income levels) per year?
Make the answer very short. 37.87. What is the average Area (% of total land area) in Canada per year?
Make the answer very short. 38.2. What is the average Area (% of total land area) in Paraguay per year?
Offer a very short reply. 43.01. What is the average Area (% of total land area) of Turks and Caicos Islands per year?
Offer a very short reply. 36.21. In the year 2006, what is the difference between the Area (% of total land area) in Europe(all income levels) and Area (% of total land area) in Canada?
Make the answer very short. -0.56. In the year 2006, what is the difference between the Area (% of total land area) of Europe(all income levels) and Area (% of total land area) of Paraguay?
Offer a very short reply. -8.08. In the year 2006, what is the difference between the Area (% of total land area) of Europe(all income levels) and Area (% of total land area) of Turks and Caicos Islands?
Your answer should be compact. 1.45. In the year 2006, what is the difference between the Area (% of total land area) in Canada and Area (% of total land area) in Paraguay?
Your answer should be very brief. -7.52. In the year 2006, what is the difference between the Area (% of total land area) of Canada and Area (% of total land area) of Turks and Caicos Islands?
Offer a very short reply. 2.01. In the year 2006, what is the difference between the Area (% of total land area) in Paraguay and Area (% of total land area) in Turks and Caicos Islands?
Your response must be concise. 9.52. In the year 2007, what is the difference between the Area (% of total land area) of Europe(all income levels) and Area (% of total land area) of Canada?
Make the answer very short. -0.48. In the year 2007, what is the difference between the Area (% of total land area) in Europe(all income levels) and Area (% of total land area) in Paraguay?
Ensure brevity in your answer.  -7.24. In the year 2007, what is the difference between the Area (% of total land area) in Europe(all income levels) and Area (% of total land area) in Turks and Caicos Islands?
Offer a terse response. 1.52. In the year 2007, what is the difference between the Area (% of total land area) of Canada and Area (% of total land area) of Paraguay?
Give a very brief answer. -6.76. In the year 2007, what is the difference between the Area (% of total land area) of Canada and Area (% of total land area) of Turks and Caicos Islands?
Your answer should be compact. 2. In the year 2007, what is the difference between the Area (% of total land area) of Paraguay and Area (% of total land area) of Turks and Caicos Islands?
Your answer should be very brief. 8.76. In the year 2008, what is the difference between the Area (% of total land area) in Europe(all income levels) and Area (% of total land area) in Canada?
Your answer should be very brief. -0.4. In the year 2008, what is the difference between the Area (% of total land area) of Europe(all income levels) and Area (% of total land area) of Paraguay?
Your answer should be compact. -6.4. In the year 2008, what is the difference between the Area (% of total land area) of Europe(all income levels) and Area (% of total land area) of Turks and Caicos Islands?
Give a very brief answer. 1.59. In the year 2008, what is the difference between the Area (% of total land area) of Canada and Area (% of total land area) of Paraguay?
Your answer should be compact. -5.99. In the year 2008, what is the difference between the Area (% of total land area) in Canada and Area (% of total land area) in Turks and Caicos Islands?
Your answer should be very brief. 1.99. In the year 2008, what is the difference between the Area (% of total land area) in Paraguay and Area (% of total land area) in Turks and Caicos Islands?
Ensure brevity in your answer.  7.99. In the year 2009, what is the difference between the Area (% of total land area) in Europe(all income levels) and Area (% of total land area) in Canada?
Ensure brevity in your answer.  -0.32. In the year 2009, what is the difference between the Area (% of total land area) of Europe(all income levels) and Area (% of total land area) of Paraguay?
Your answer should be very brief. -5.56. In the year 2009, what is the difference between the Area (% of total land area) of Europe(all income levels) and Area (% of total land area) of Turks and Caicos Islands?
Offer a terse response. 1.66. In the year 2009, what is the difference between the Area (% of total land area) in Canada and Area (% of total land area) in Paraguay?
Provide a succinct answer. -5.23. In the year 2009, what is the difference between the Area (% of total land area) of Canada and Area (% of total land area) of Turks and Caicos Islands?
Your answer should be compact. 1.99. In the year 2009, what is the difference between the Area (% of total land area) of Paraguay and Area (% of total land area) of Turks and Caicos Islands?
Make the answer very short. 7.22. In the year 2010, what is the difference between the Area (% of total land area) in Europe(all income levels) and Area (% of total land area) in Canada?
Ensure brevity in your answer.  -0.25. In the year 2010, what is the difference between the Area (% of total land area) of Europe(all income levels) and Area (% of total land area) of Paraguay?
Ensure brevity in your answer.  -4.72. In the year 2010, what is the difference between the Area (% of total land area) of Europe(all income levels) and Area (% of total land area) of Turks and Caicos Islands?
Provide a short and direct response. 1.73. In the year 2010, what is the difference between the Area (% of total land area) in Canada and Area (% of total land area) in Paraguay?
Provide a succinct answer. -4.47. In the year 2010, what is the difference between the Area (% of total land area) in Canada and Area (% of total land area) in Turks and Caicos Islands?
Your answer should be compact. 1.98. In the year 2010, what is the difference between the Area (% of total land area) in Paraguay and Area (% of total land area) in Turks and Caicos Islands?
Ensure brevity in your answer.  6.45. In the year 2011, what is the difference between the Area (% of total land area) in Europe(all income levels) and Area (% of total land area) in Canada?
Provide a short and direct response. -0.23. In the year 2011, what is the difference between the Area (% of total land area) of Europe(all income levels) and Area (% of total land area) of Paraguay?
Offer a terse response. -3.88. In the year 2011, what is the difference between the Area (% of total land area) in Europe(all income levels) and Area (% of total land area) in Turks and Caicos Islands?
Your answer should be very brief. 1.75. In the year 2011, what is the difference between the Area (% of total land area) of Canada and Area (% of total land area) of Paraguay?
Ensure brevity in your answer.  -3.66. In the year 2011, what is the difference between the Area (% of total land area) in Canada and Area (% of total land area) in Turks and Caicos Islands?
Keep it short and to the point. 1.98. In the year 2011, what is the difference between the Area (% of total land area) of Paraguay and Area (% of total land area) of Turks and Caicos Islands?
Make the answer very short. 5.63. In the year 2012, what is the difference between the Area (% of total land area) of Europe(all income levels) and Area (% of total land area) of Canada?
Offer a very short reply. -0.2. In the year 2012, what is the difference between the Area (% of total land area) of Europe(all income levels) and Area (% of total land area) of Paraguay?
Give a very brief answer. -3.04. In the year 2012, what is the difference between the Area (% of total land area) in Europe(all income levels) and Area (% of total land area) in Turks and Caicos Islands?
Provide a short and direct response. 1.77. In the year 2012, what is the difference between the Area (% of total land area) of Canada and Area (% of total land area) of Paraguay?
Give a very brief answer. -2.84. In the year 2012, what is the difference between the Area (% of total land area) in Canada and Area (% of total land area) in Turks and Caicos Islands?
Make the answer very short. 1.97. In the year 2012, what is the difference between the Area (% of total land area) in Paraguay and Area (% of total land area) in Turks and Caicos Islands?
Your answer should be compact. 4.81. In the year 2013, what is the difference between the Area (% of total land area) in Europe(all income levels) and Area (% of total land area) in Canada?
Keep it short and to the point. -0.17. In the year 2013, what is the difference between the Area (% of total land area) of Europe(all income levels) and Area (% of total land area) of Paraguay?
Offer a very short reply. -2.2. In the year 2013, what is the difference between the Area (% of total land area) in Europe(all income levels) and Area (% of total land area) in Turks and Caicos Islands?
Offer a very short reply. 1.79. In the year 2013, what is the difference between the Area (% of total land area) of Canada and Area (% of total land area) of Paraguay?
Give a very brief answer. -2.03. In the year 2013, what is the difference between the Area (% of total land area) of Canada and Area (% of total land area) of Turks and Caicos Islands?
Make the answer very short. 1.97. In the year 2013, what is the difference between the Area (% of total land area) in Paraguay and Area (% of total land area) in Turks and Caicos Islands?
Give a very brief answer. 4. What is the ratio of the Area (% of total land area) in Canada in 2006 to that in 2007?
Keep it short and to the point. 1. What is the ratio of the Area (% of total land area) of Paraguay in 2006 to that in 2007?
Offer a terse response. 1.02. What is the ratio of the Area (% of total land area) of Turks and Caicos Islands in 2006 to that in 2007?
Ensure brevity in your answer.  1. What is the ratio of the Area (% of total land area) of Paraguay in 2006 to that in 2008?
Keep it short and to the point. 1.03. What is the ratio of the Area (% of total land area) in Turks and Caicos Islands in 2006 to that in 2008?
Your answer should be compact. 1. What is the ratio of the Area (% of total land area) of Canada in 2006 to that in 2009?
Offer a terse response. 1. What is the ratio of the Area (% of total land area) in Paraguay in 2006 to that in 2009?
Offer a very short reply. 1.05. What is the ratio of the Area (% of total land area) of Turks and Caicos Islands in 2006 to that in 2009?
Your response must be concise. 1. What is the ratio of the Area (% of total land area) in Europe(all income levels) in 2006 to that in 2010?
Provide a succinct answer. 0.99. What is the ratio of the Area (% of total land area) of Paraguay in 2006 to that in 2010?
Provide a succinct answer. 1.07. What is the ratio of the Area (% of total land area) of Turks and Caicos Islands in 2006 to that in 2010?
Give a very brief answer. 1. What is the ratio of the Area (% of total land area) of Europe(all income levels) in 2006 to that in 2011?
Keep it short and to the point. 0.99. What is the ratio of the Area (% of total land area) of Paraguay in 2006 to that in 2011?
Ensure brevity in your answer.  1.09. What is the ratio of the Area (% of total land area) in Turks and Caicos Islands in 2006 to that in 2011?
Provide a succinct answer. 1. What is the ratio of the Area (% of total land area) in Europe(all income levels) in 2006 to that in 2012?
Give a very brief answer. 0.99. What is the ratio of the Area (% of total land area) in Canada in 2006 to that in 2012?
Provide a short and direct response. 1. What is the ratio of the Area (% of total land area) of Paraguay in 2006 to that in 2012?
Offer a terse response. 1.11. What is the ratio of the Area (% of total land area) of Europe(all income levels) in 2006 to that in 2013?
Provide a succinct answer. 0.99. What is the ratio of the Area (% of total land area) in Canada in 2006 to that in 2013?
Your response must be concise. 1. What is the ratio of the Area (% of total land area) of Paraguay in 2006 to that in 2013?
Your answer should be compact. 1.14. What is the ratio of the Area (% of total land area) in Turks and Caicos Islands in 2006 to that in 2013?
Offer a very short reply. 1. What is the ratio of the Area (% of total land area) in Europe(all income levels) in 2007 to that in 2008?
Offer a terse response. 1. What is the ratio of the Area (% of total land area) of Paraguay in 2007 to that in 2008?
Offer a very short reply. 1.02. What is the ratio of the Area (% of total land area) of Europe(all income levels) in 2007 to that in 2009?
Make the answer very short. 1. What is the ratio of the Area (% of total land area) in Paraguay in 2007 to that in 2009?
Your response must be concise. 1.04. What is the ratio of the Area (% of total land area) of Europe(all income levels) in 2007 to that in 2010?
Provide a short and direct response. 0.99. What is the ratio of the Area (% of total land area) of Canada in 2007 to that in 2010?
Give a very brief answer. 1. What is the ratio of the Area (% of total land area) of Paraguay in 2007 to that in 2010?
Keep it short and to the point. 1.05. What is the ratio of the Area (% of total land area) of Paraguay in 2007 to that in 2011?
Ensure brevity in your answer.  1.07. What is the ratio of the Area (% of total land area) of Turks and Caicos Islands in 2007 to that in 2011?
Ensure brevity in your answer.  1. What is the ratio of the Area (% of total land area) in Europe(all income levels) in 2007 to that in 2012?
Your answer should be very brief. 0.99. What is the ratio of the Area (% of total land area) in Canada in 2007 to that in 2012?
Provide a short and direct response. 1. What is the ratio of the Area (% of total land area) of Paraguay in 2007 to that in 2012?
Your answer should be very brief. 1.1. What is the ratio of the Area (% of total land area) of Turks and Caicos Islands in 2007 to that in 2012?
Provide a succinct answer. 1. What is the ratio of the Area (% of total land area) in Canada in 2007 to that in 2013?
Offer a very short reply. 1. What is the ratio of the Area (% of total land area) in Paraguay in 2007 to that in 2013?
Keep it short and to the point. 1.12. What is the ratio of the Area (% of total land area) of Paraguay in 2008 to that in 2009?
Give a very brief answer. 1.02. What is the ratio of the Area (% of total land area) of Paraguay in 2008 to that in 2010?
Offer a terse response. 1.04. What is the ratio of the Area (% of total land area) of Europe(all income levels) in 2008 to that in 2011?
Provide a short and direct response. 1. What is the ratio of the Area (% of total land area) in Paraguay in 2008 to that in 2011?
Give a very brief answer. 1.06. What is the ratio of the Area (% of total land area) of Paraguay in 2008 to that in 2012?
Your response must be concise. 1.08. What is the ratio of the Area (% of total land area) of Turks and Caicos Islands in 2008 to that in 2012?
Offer a terse response. 1. What is the ratio of the Area (% of total land area) of Europe(all income levels) in 2008 to that in 2013?
Offer a terse response. 0.99. What is the ratio of the Area (% of total land area) in Canada in 2008 to that in 2013?
Your answer should be very brief. 1. What is the ratio of the Area (% of total land area) of Paraguay in 2008 to that in 2013?
Your answer should be very brief. 1.1. What is the ratio of the Area (% of total land area) of Europe(all income levels) in 2009 to that in 2010?
Keep it short and to the point. 1. What is the ratio of the Area (% of total land area) of Canada in 2009 to that in 2010?
Ensure brevity in your answer.  1. What is the ratio of the Area (% of total land area) of Paraguay in 2009 to that in 2010?
Make the answer very short. 1.02. What is the ratio of the Area (% of total land area) of Turks and Caicos Islands in 2009 to that in 2010?
Provide a short and direct response. 1. What is the ratio of the Area (% of total land area) of Europe(all income levels) in 2009 to that in 2011?
Provide a short and direct response. 1. What is the ratio of the Area (% of total land area) of Paraguay in 2009 to that in 2011?
Your answer should be very brief. 1.04. What is the ratio of the Area (% of total land area) in Europe(all income levels) in 2009 to that in 2012?
Offer a very short reply. 1. What is the ratio of the Area (% of total land area) of Canada in 2009 to that in 2012?
Provide a short and direct response. 1. What is the ratio of the Area (% of total land area) of Paraguay in 2009 to that in 2012?
Give a very brief answer. 1.06. What is the ratio of the Area (% of total land area) of Paraguay in 2009 to that in 2013?
Your answer should be very brief. 1.08. What is the ratio of the Area (% of total land area) of Turks and Caicos Islands in 2009 to that in 2013?
Keep it short and to the point. 1. What is the ratio of the Area (% of total land area) in Canada in 2010 to that in 2011?
Offer a very short reply. 1. What is the ratio of the Area (% of total land area) of Paraguay in 2010 to that in 2011?
Provide a succinct answer. 1.02. What is the ratio of the Area (% of total land area) in Europe(all income levels) in 2010 to that in 2012?
Your response must be concise. 1. What is the ratio of the Area (% of total land area) of Canada in 2010 to that in 2012?
Your answer should be very brief. 1. What is the ratio of the Area (% of total land area) of Paraguay in 2010 to that in 2012?
Ensure brevity in your answer.  1.04. What is the ratio of the Area (% of total land area) of Turks and Caicos Islands in 2010 to that in 2012?
Give a very brief answer. 1. What is the ratio of the Area (% of total land area) of Paraguay in 2010 to that in 2013?
Make the answer very short. 1.06. What is the ratio of the Area (% of total land area) in Turks and Caicos Islands in 2010 to that in 2013?
Keep it short and to the point. 1. What is the ratio of the Area (% of total land area) of Paraguay in 2011 to that in 2012?
Provide a succinct answer. 1.02. What is the ratio of the Area (% of total land area) in Turks and Caicos Islands in 2011 to that in 2012?
Give a very brief answer. 1. What is the ratio of the Area (% of total land area) in Paraguay in 2011 to that in 2013?
Offer a terse response. 1.04. What is the ratio of the Area (% of total land area) in Turks and Caicos Islands in 2011 to that in 2013?
Your answer should be compact. 1. What is the ratio of the Area (% of total land area) of Canada in 2012 to that in 2013?
Your response must be concise. 1. What is the ratio of the Area (% of total land area) in Paraguay in 2012 to that in 2013?
Provide a succinct answer. 1.02. What is the difference between the highest and the second highest Area (% of total land area) in Europe(all income levels)?
Your answer should be very brief. 0.02. What is the difference between the highest and the second highest Area (% of total land area) in Canada?
Offer a terse response. 0.01. What is the difference between the highest and the second highest Area (% of total land area) of Paraguay?
Offer a terse response. 0.77. What is the difference between the highest and the lowest Area (% of total land area) in Europe(all income levels)?
Your answer should be very brief. 0.35. What is the difference between the highest and the lowest Area (% of total land area) in Canada?
Keep it short and to the point. 0.04. What is the difference between the highest and the lowest Area (% of total land area) in Paraguay?
Provide a short and direct response. 5.53. 